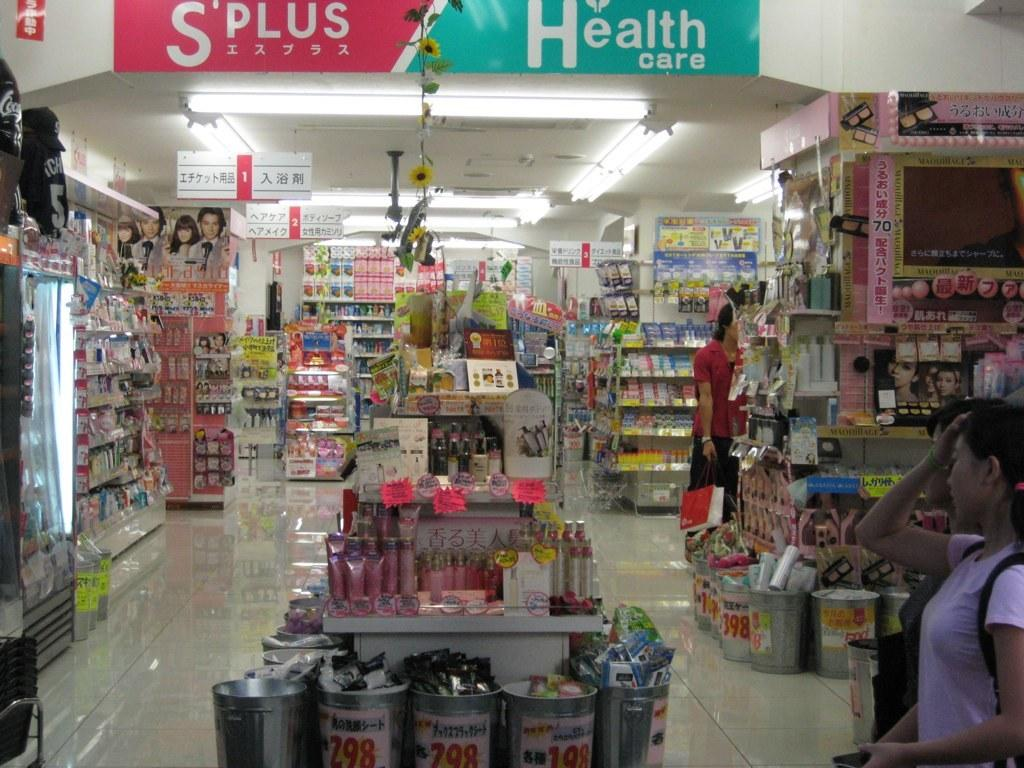<image>
Write a terse but informative summary of the picture. A grocery store has a green Health care banner displayed. 